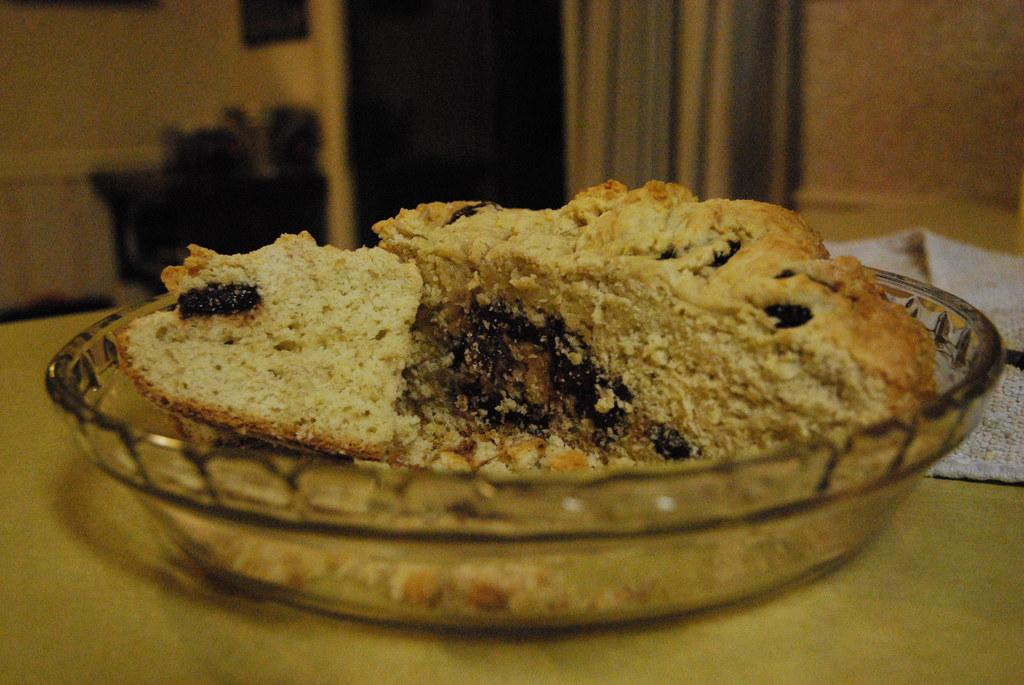What is on the table in the image? There is a glass bowl and a cake on the table. What is covering the table in the image? There is a cloth on the table. What can be seen in the background of the image? There is a door in the background. How close is the door to the table? The door is near the table. What is near the wall in the image? There is a cloth near the wall. What type of hose is being used to cook the cake in the image? There is no hose present in the image, and the cake is not being cooked; it is already on the table. Can you tell me which minister is responsible for the cloth near the wall in the image? There is no minister mentioned or depicted in the image, and the cloth near the wall is not associated with any specific person or role. 